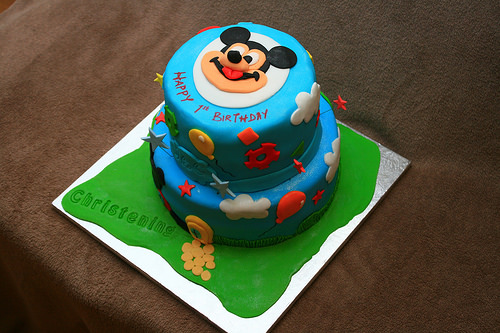<image>
Is the cake on the table? Yes. Looking at the image, I can see the cake is positioned on top of the table, with the table providing support. 